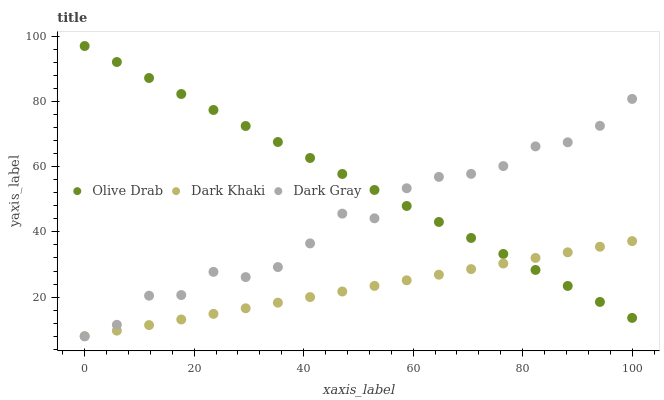Does Dark Khaki have the minimum area under the curve?
Answer yes or no. Yes. Does Olive Drab have the maximum area under the curve?
Answer yes or no. Yes. Does Dark Gray have the minimum area under the curve?
Answer yes or no. No. Does Dark Gray have the maximum area under the curve?
Answer yes or no. No. Is Dark Khaki the smoothest?
Answer yes or no. Yes. Is Dark Gray the roughest?
Answer yes or no. Yes. Is Olive Drab the smoothest?
Answer yes or no. No. Is Olive Drab the roughest?
Answer yes or no. No. Does Dark Khaki have the lowest value?
Answer yes or no. Yes. Does Olive Drab have the lowest value?
Answer yes or no. No. Does Olive Drab have the highest value?
Answer yes or no. Yes. Does Dark Gray have the highest value?
Answer yes or no. No. Does Dark Khaki intersect Dark Gray?
Answer yes or no. Yes. Is Dark Khaki less than Dark Gray?
Answer yes or no. No. Is Dark Khaki greater than Dark Gray?
Answer yes or no. No. 